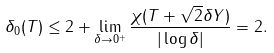Convert formula to latex. <formula><loc_0><loc_0><loc_500><loc_500>\delta _ { 0 } ( T ) \leq 2 + \lim _ { \delta \to 0 ^ { + } } \frac { \chi ( T + \sqrt { 2 } \delta Y ) } { | \log \delta | } = 2 .</formula> 